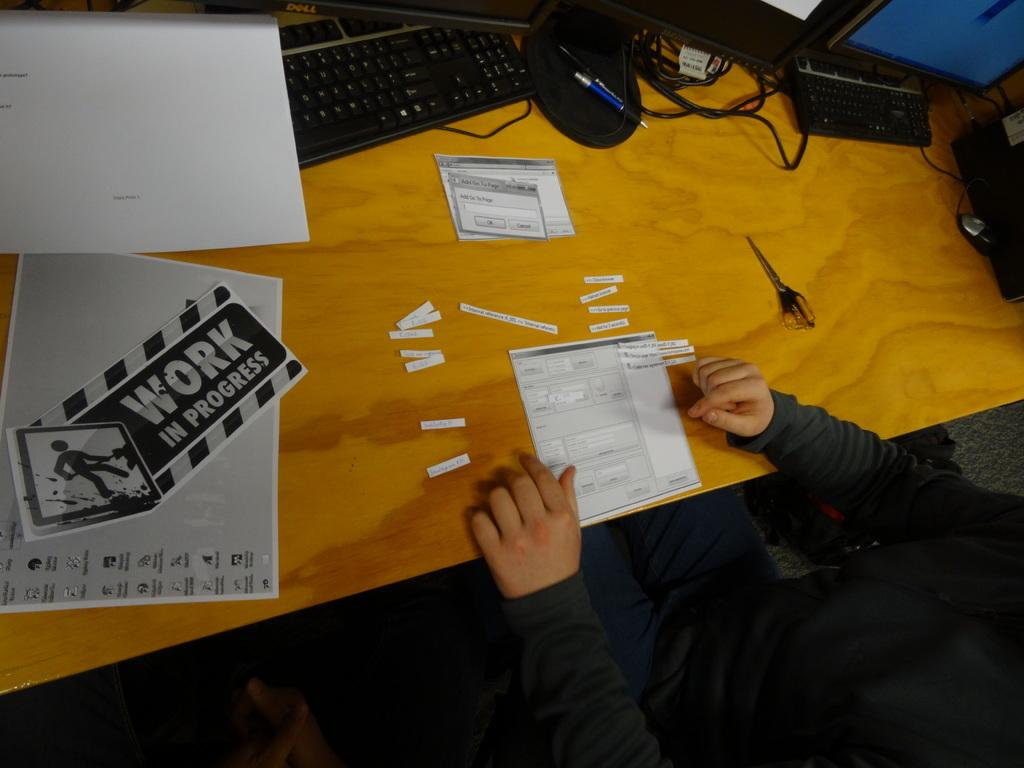Provide a one-sentence caption for the provided image. A person is cutting paper at a desk with a sign that says Work In Progress. 